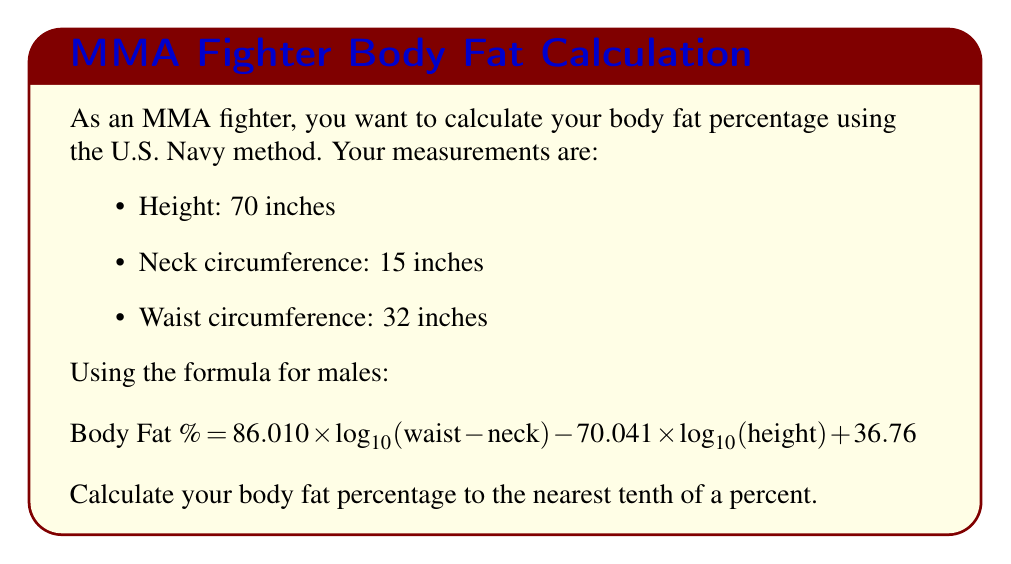Teach me how to tackle this problem. Let's solve this step-by-step:

1) First, we need to calculate $(\text{waist} - \text{neck})$:
   $32 - 15 = 17$ inches

2) Now, let's substitute the values into the formula:
   $$ \text{Body Fat \%} = 86.010 \times \log_{10}(17) - 70.041 \times \log_{10}(70) + 36.76 $$

3) Calculate the logarithms:
   $\log_{10}(17) \approx 1.2304$
   $\log_{10}(70) \approx 1.8451$

4) Substitute these values:
   $$ \text{Body Fat \%} = 86.010 \times 1.2304 - 70.041 \times 1.8451 + 36.76 $$

5) Multiply:
   $$ \text{Body Fat \%} = 105.8267 - 129.2327 + 36.76 $$

6) Add and subtract:
   $$ \text{Body Fat \%} = 13.3540 $$

7) Rounding to the nearest tenth:
   $$ \text{Body Fat \%} = 13.4\% $$
Answer: 13.4% 